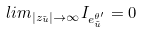Convert formula to latex. <formula><loc_0><loc_0><loc_500><loc_500>l i m _ { | z _ { \tilde { u } } | \rightarrow \infty } I _ { e _ { \tilde { u } } ^ { \theta ^ { \prime } } } = 0</formula> 